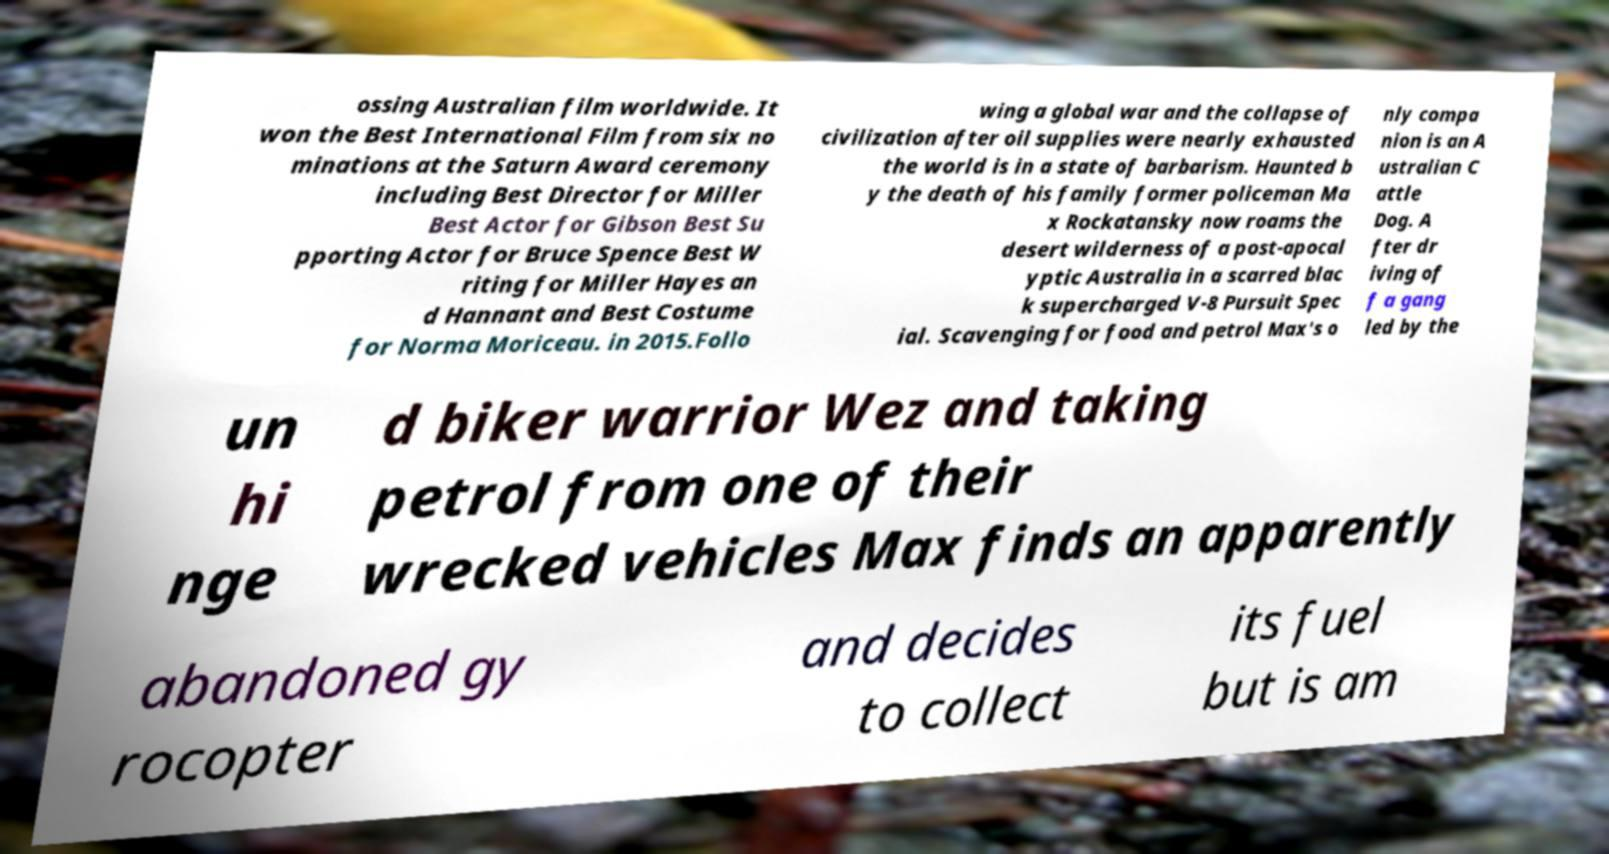Can you accurately transcribe the text from the provided image for me? ossing Australian film worldwide. It won the Best International Film from six no minations at the Saturn Award ceremony including Best Director for Miller Best Actor for Gibson Best Su pporting Actor for Bruce Spence Best W riting for Miller Hayes an d Hannant and Best Costume for Norma Moriceau. in 2015.Follo wing a global war and the collapse of civilization after oil supplies were nearly exhausted the world is in a state of barbarism. Haunted b y the death of his family former policeman Ma x Rockatansky now roams the desert wilderness of a post-apocal yptic Australia in a scarred blac k supercharged V-8 Pursuit Spec ial. Scavenging for food and petrol Max's o nly compa nion is an A ustralian C attle Dog. A fter dr iving of f a gang led by the un hi nge d biker warrior Wez and taking petrol from one of their wrecked vehicles Max finds an apparently abandoned gy rocopter and decides to collect its fuel but is am 